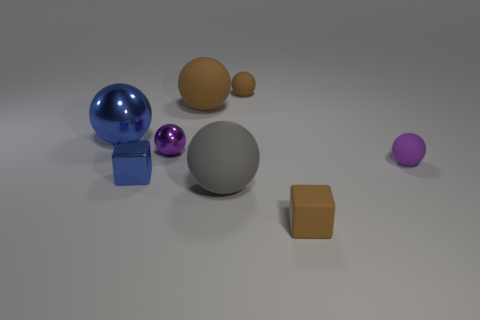Subtract all brown balls. How many balls are left? 4 Subtract all purple balls. How many balls are left? 4 Subtract 3 balls. How many balls are left? 3 Subtract all blue balls. Subtract all cyan blocks. How many balls are left? 5 Add 1 small blocks. How many objects exist? 9 Subtract all spheres. How many objects are left? 2 Add 3 blue metallic balls. How many blue metallic balls exist? 4 Subtract 0 green blocks. How many objects are left? 8 Subtract all small metallic objects. Subtract all big gray matte spheres. How many objects are left? 5 Add 5 big rubber spheres. How many big rubber spheres are left? 7 